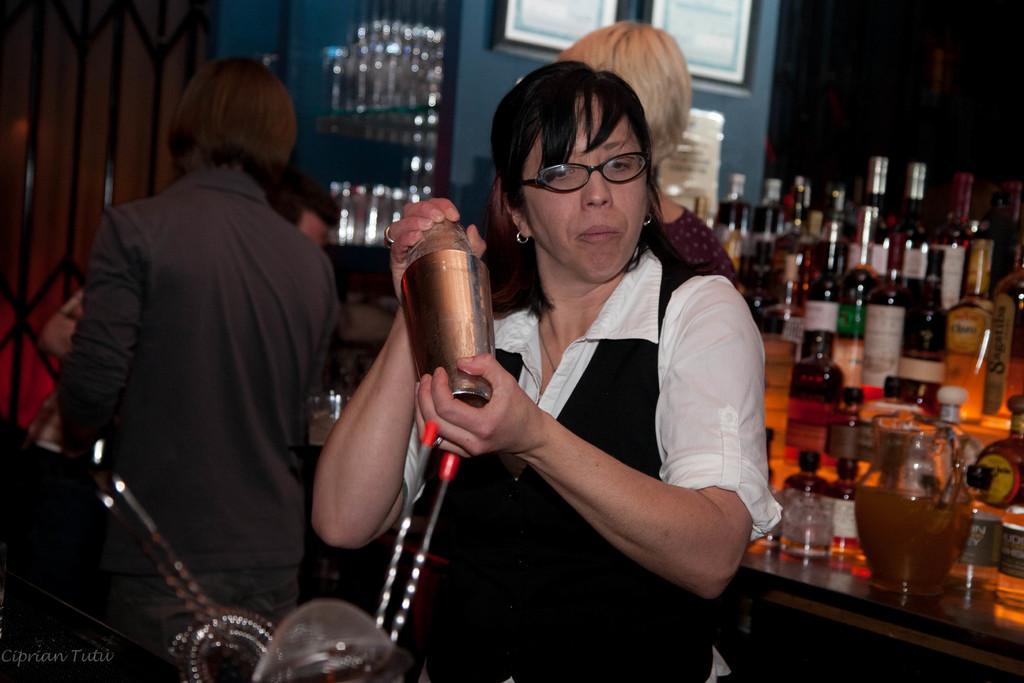Could you give a brief overview of what you see in this image? This picture is clicked inside. In the center there is a woman holding an object and standing on the ground. In the foreground there are some objects. On the left there are two persons standing on the ground. On the right we can see there are many number of bottles and some other objects are placed on the top of the table. In the background we can see the door, picture frames hanging on the wall and a person seems to be standing on the ground and there are many other objects. 